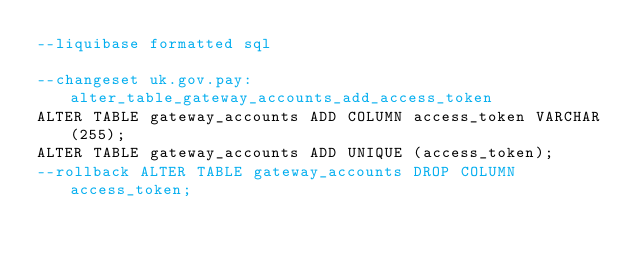<code> <loc_0><loc_0><loc_500><loc_500><_SQL_>--liquibase formatted sql

--changeset uk.gov.pay:alter_table_gateway_accounts_add_access_token
ALTER TABLE gateway_accounts ADD COLUMN access_token VARCHAR(255);
ALTER TABLE gateway_accounts ADD UNIQUE (access_token);
--rollback ALTER TABLE gateway_accounts DROP COLUMN access_token;
</code> 